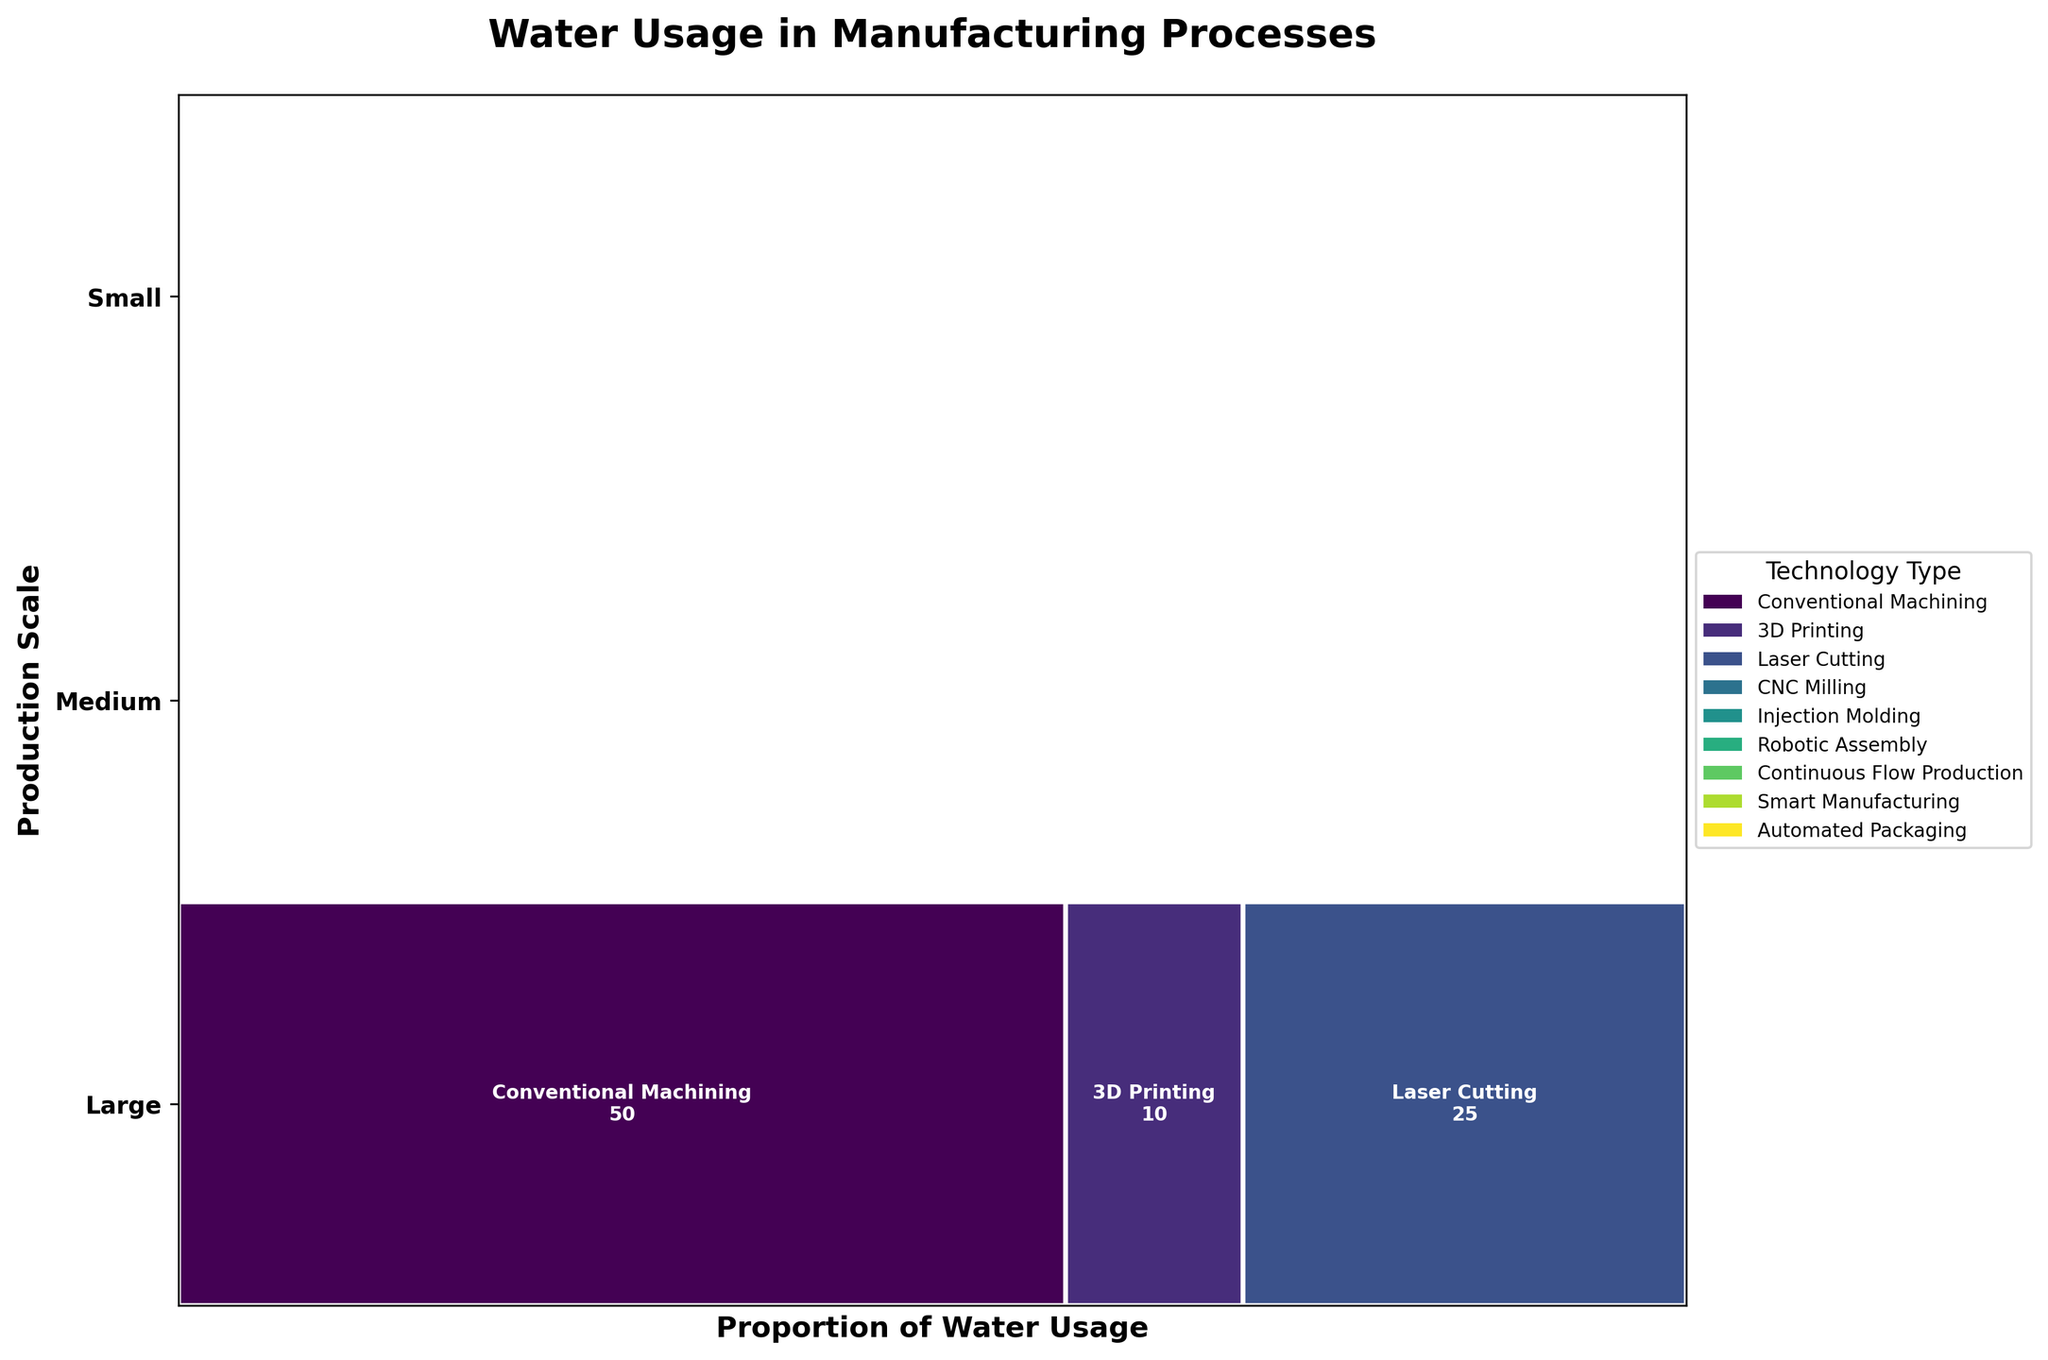What is the title of the plot? The title of the plot is usually found at the top, formatted in bold to grab attention. In this case, it clearly states "Water Usage in Manufacturing Processes".
Answer: Water Usage in Manufacturing Processes Which production scale uses the least amount of water in 3D Printing? By examining the widths of the rectangular segments labeled "3D Printing" at each production scale, we can identify that the "Small" scale segment is the smallest. This indicates it uses the least water.
Answer: Small How many technology types are represented in the plot? The legend on the right side of the plot shows different colored rectangles for each technology type. Counting these shows that there are six technology types.
Answer: Six What is the widest segment for Large production scale, and how much water does it use? For the "Large" category, look for the segment with the largest width. The "Continuous Flow Production" has the widest segment, meaning it consumes the most water. The figure inside indicates it uses 500 m³/day.
Answer: Continuous Flow Production, 500 m³/day Which production scale has the highest proportion of water usage for Robotic Assembly? By checking each row for the "Robotic Assembly" segment and comparing their widths, the "Medium" scale has the highest proportion of water usage.
Answer: Medium What is the total water usage for Small scale production? Add the water usage values of each technology type under the "Small" scale: Conventional Machining (50 m³/day), 3D Printing (10 m³/day), Laser Cutting (25 m³/day).
Answer: 85 m³/day Does any technology type have equal water usage across different production scales? Carefully compare the values within the segments of each technology type across all production scales. None of the values are equal across the production scales.
Answer: No Which technology type has the highest sustainability rating and what is its water consumption at the largest scale? By observing the colors and text, "Smart Manufacturing" has the highest sustainability rating at the largest scale. Its segment shows a water consumption of 300 m³/day.
Answer: Smart Manufacturing, 300 m³/day How does the water usage of Conventional Machining compare between Small and Medium production scales? Find the segments for "Conventional Machining" under both "Small" and "Medium" scales in the plot. The usage is 50 m³/day for Small and does not exist in the Medium category.
Answer: 50 m³/day, absent in Medium Which production scale has the most balanced water usage distribution among its technology types? Examine the production scale rows to see which has segments closest in width, indicating a more balanced distribution. The "Medium" scale with its segments being relatively balanced shows the most balanced distribution.
Answer: Medium 